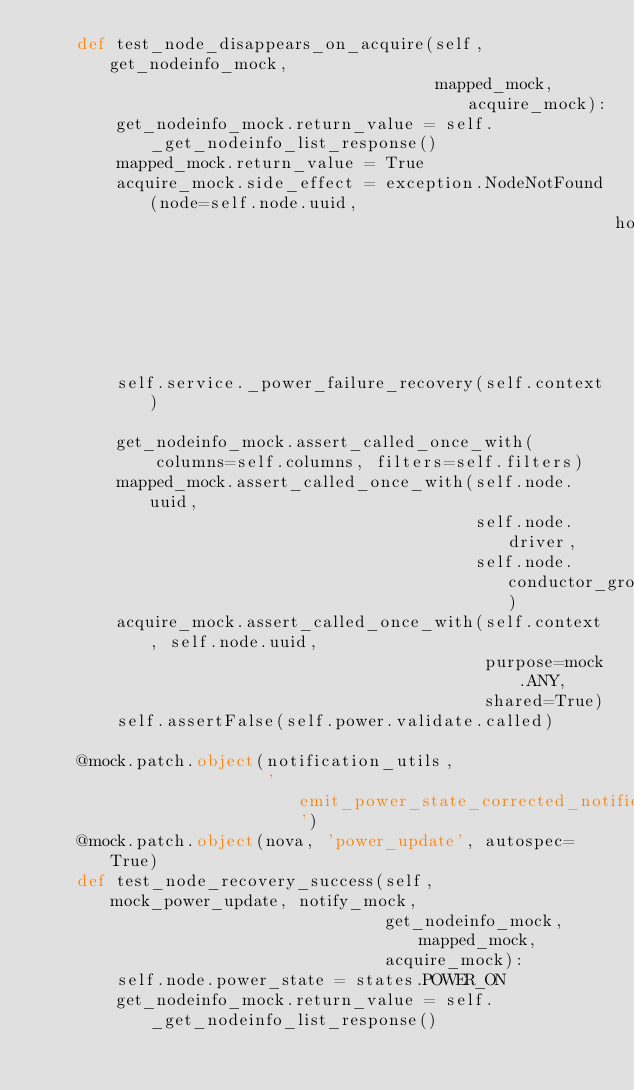<code> <loc_0><loc_0><loc_500><loc_500><_Python_>    def test_node_disappears_on_acquire(self, get_nodeinfo_mock,
                                        mapped_mock, acquire_mock):
        get_nodeinfo_mock.return_value = self._get_nodeinfo_list_response()
        mapped_mock.return_value = True
        acquire_mock.side_effect = exception.NodeNotFound(node=self.node.uuid,
                                                          host='fake')

        self.service._power_failure_recovery(self.context)

        get_nodeinfo_mock.assert_called_once_with(
            columns=self.columns, filters=self.filters)
        mapped_mock.assert_called_once_with(self.node.uuid,
                                            self.node.driver,
                                            self.node.conductor_group)
        acquire_mock.assert_called_once_with(self.context, self.node.uuid,
                                             purpose=mock.ANY,
                                             shared=True)
        self.assertFalse(self.power.validate.called)

    @mock.patch.object(notification_utils,
                       'emit_power_state_corrected_notification')
    @mock.patch.object(nova, 'power_update', autospec=True)
    def test_node_recovery_success(self, mock_power_update, notify_mock,
                                   get_nodeinfo_mock, mapped_mock,
                                   acquire_mock):
        self.node.power_state = states.POWER_ON
        get_nodeinfo_mock.return_value = self._get_nodeinfo_list_response()</code> 